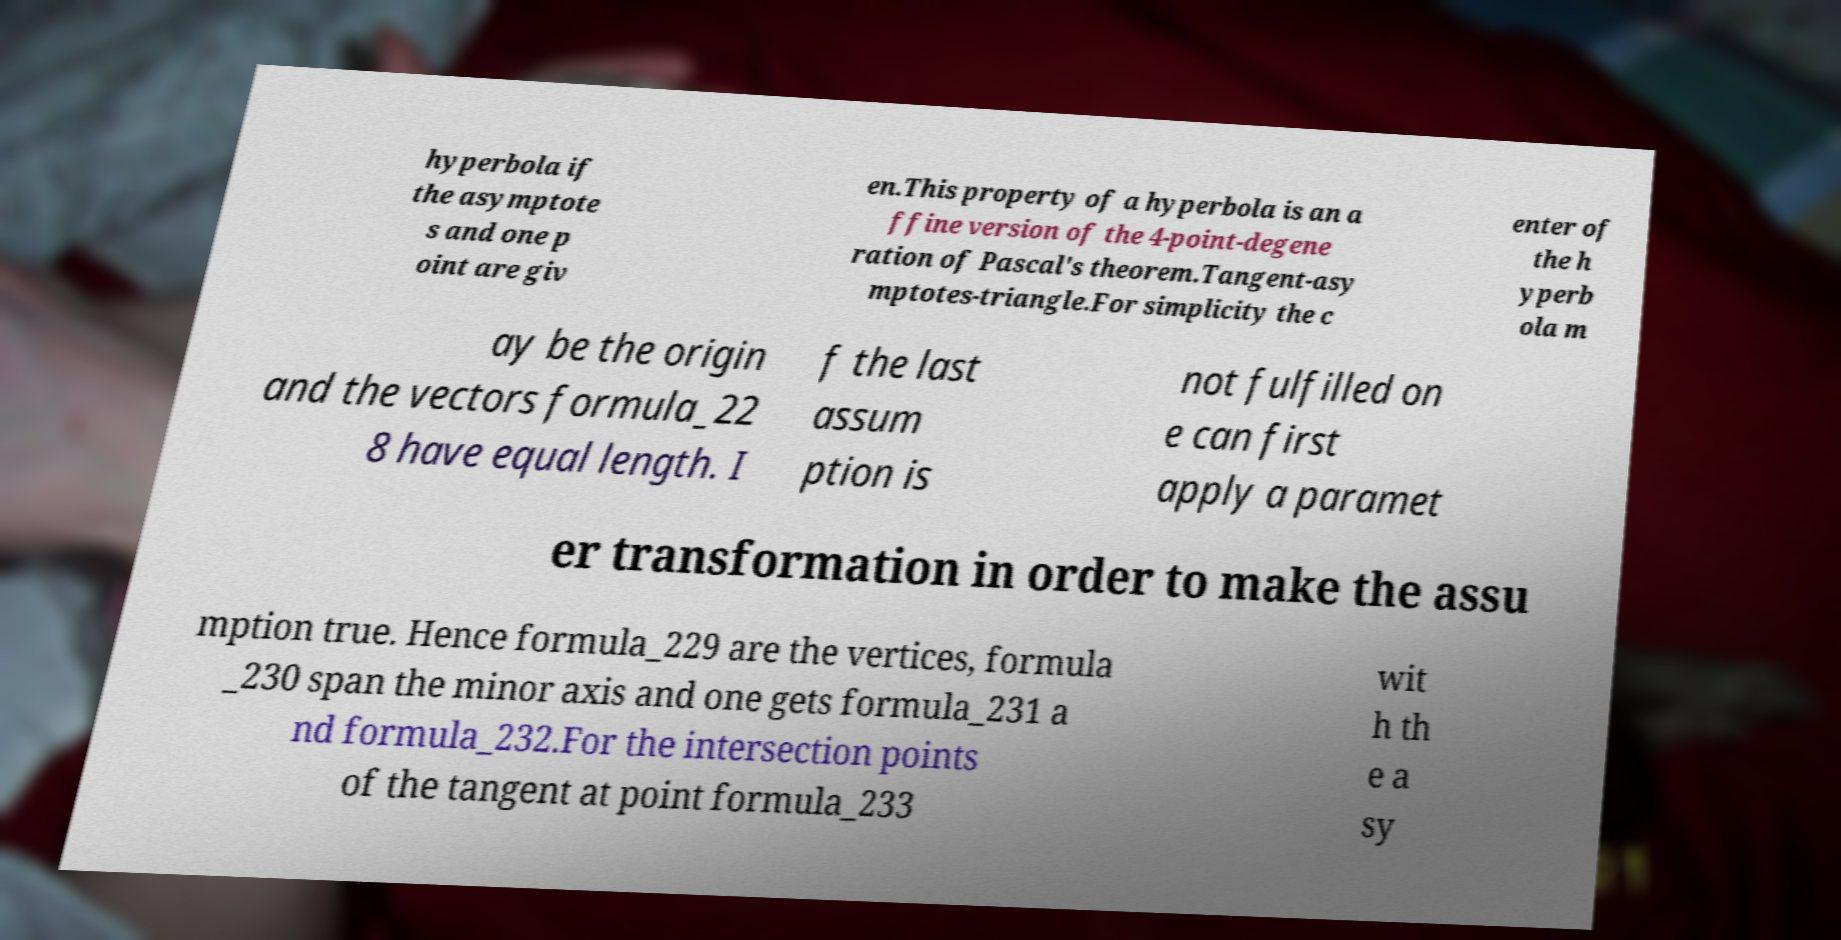Please read and relay the text visible in this image. What does it say? hyperbola if the asymptote s and one p oint are giv en.This property of a hyperbola is an a ffine version of the 4-point-degene ration of Pascal's theorem.Tangent-asy mptotes-triangle.For simplicity the c enter of the h yperb ola m ay be the origin and the vectors formula_22 8 have equal length. I f the last assum ption is not fulfilled on e can first apply a paramet er transformation in order to make the assu mption true. Hence formula_229 are the vertices, formula _230 span the minor axis and one gets formula_231 a nd formula_232.For the intersection points of the tangent at point formula_233 wit h th e a sy 